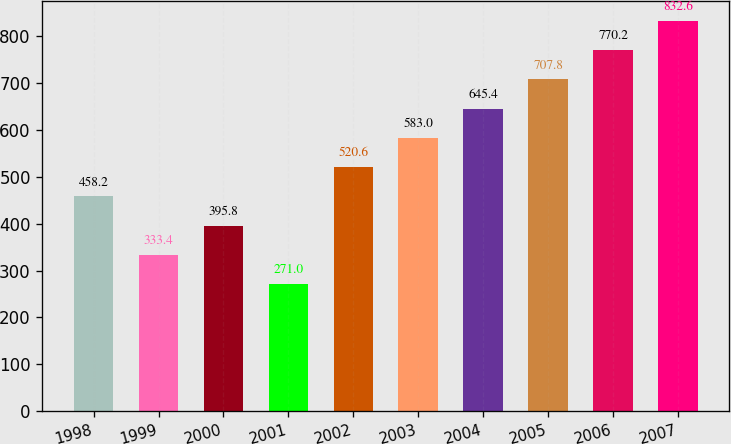Convert chart. <chart><loc_0><loc_0><loc_500><loc_500><bar_chart><fcel>1998<fcel>1999<fcel>2000<fcel>2001<fcel>2002<fcel>2003<fcel>2004<fcel>2005<fcel>2006<fcel>2007<nl><fcel>458.2<fcel>333.4<fcel>395.8<fcel>271<fcel>520.6<fcel>583<fcel>645.4<fcel>707.8<fcel>770.2<fcel>832.6<nl></chart> 